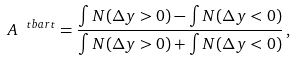<formula> <loc_0><loc_0><loc_500><loc_500>A ^ { \ t b a r t } = \frac { \int N ( \Delta y > 0 ) - \int N ( \Delta y < 0 ) } { \int N ( \Delta y > 0 ) + \int N ( \Delta y < 0 ) } \, ,</formula> 